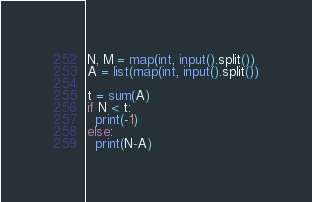<code> <loc_0><loc_0><loc_500><loc_500><_Python_>N, M = map(int, input().split())
A = list(map(int, input().split())
         
t = sum(A)
if N < t:
  print(-1)
else:
  print(N-A)</code> 